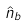Convert formula to latex. <formula><loc_0><loc_0><loc_500><loc_500>\hat { n } _ { b }</formula> 